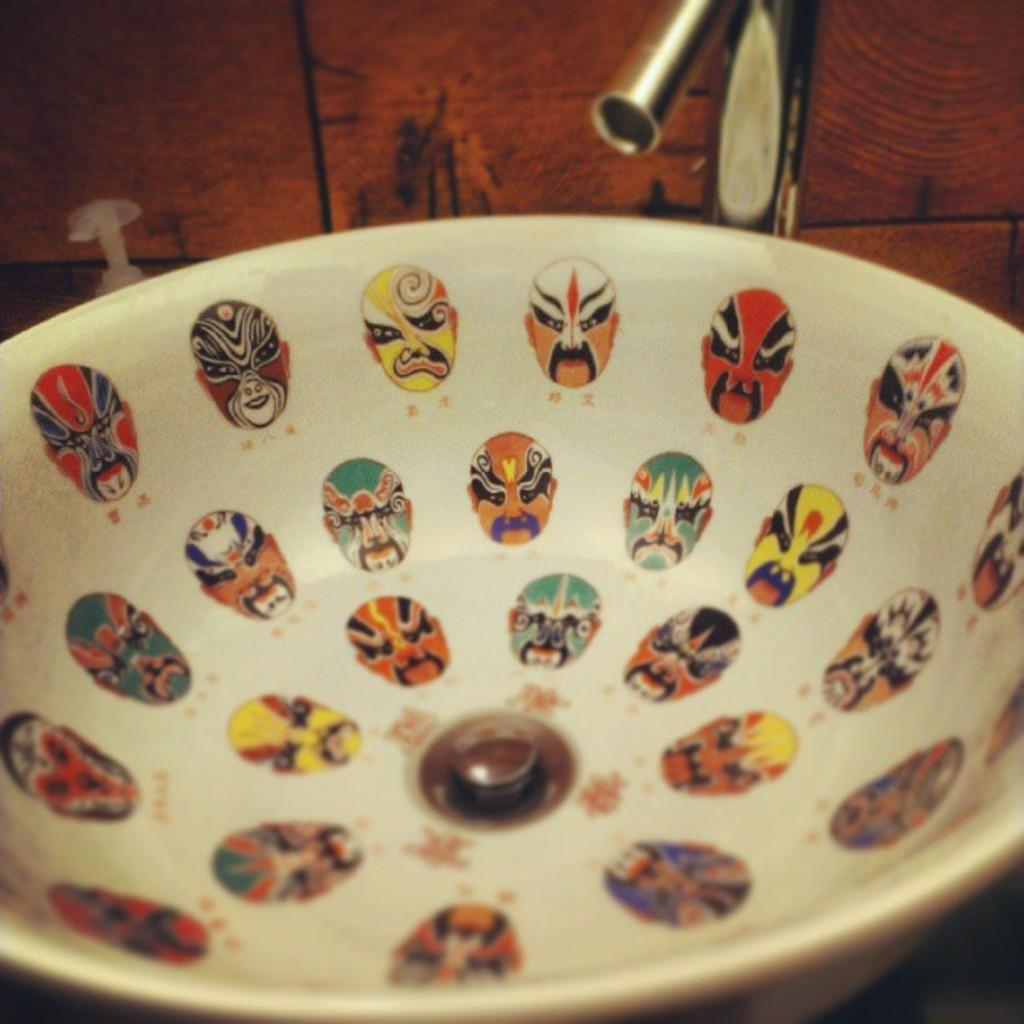What is the main object in the image? There is a bowl in the image. What color is the bowl? The bowl is white in color. What decorations are on the bowl? The bowl has stickers of faces on it. What type of surface is behind the bowl? The bowl has a wooden background. What metal object can be seen at the top of the picture? There is a metal object at the top of the picture. What type of dinner is being served at the cemetery in the image? There is no cemetery or dinner present in the image; it features a bowl with stickers of faces on a wooden background. 